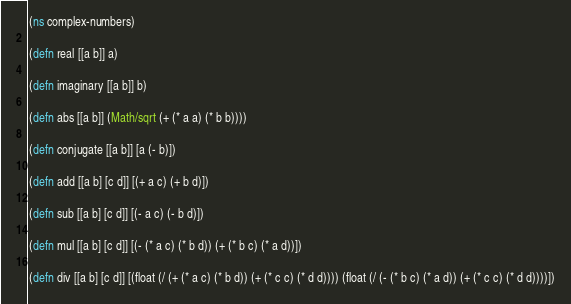Convert code to text. <code><loc_0><loc_0><loc_500><loc_500><_Clojure_>(ns complex-numbers)

(defn real [[a b]] a)

(defn imaginary [[a b]] b)

(defn abs [[a b]] (Math/sqrt (+ (* a a) (* b b))))

(defn conjugate [[a b]] [a (- b)])

(defn add [[a b] [c d]] [(+ a c) (+ b d)])

(defn sub [[a b] [c d]] [(- a c) (- b d)])

(defn mul [[a b] [c d]] [(- (* a c) (* b d)) (+ (* b c) (* a d))])

(defn div [[a b] [c d]] [(float (/ (+ (* a c) (* b d)) (+ (* c c) (* d d)))) (float (/ (- (* b c) (* a d)) (+ (* c c) (* d d))))])
</code> 